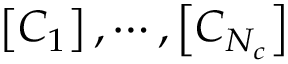Convert formula to latex. <formula><loc_0><loc_0><loc_500><loc_500>\left [ C _ { 1 } \right ] , \cdots , \left [ C _ { N _ { c } } \right ]</formula> 